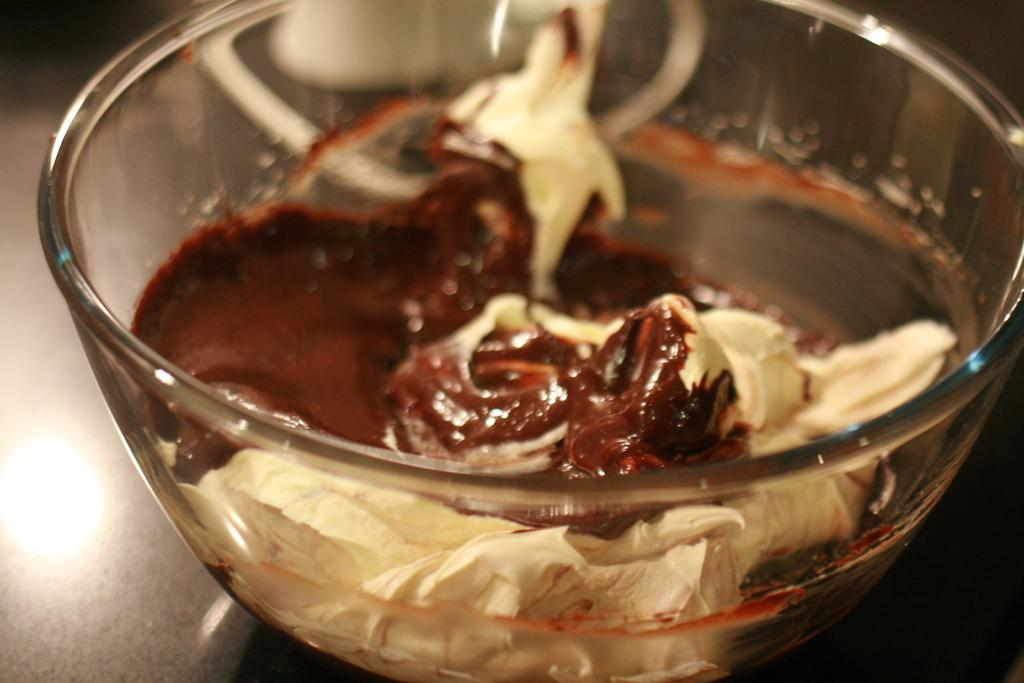What type of container is visible in the image? There is a glass bowl in the image. What is inside the glass bowl? The glass bowl contains chocolate and white cream. Where is the glass bowl located? The glass bowl is on a table. What color is the knee of the person holding the twig in the image? There is no person holding a twig in the image, and therefore no knee or color to describe. 